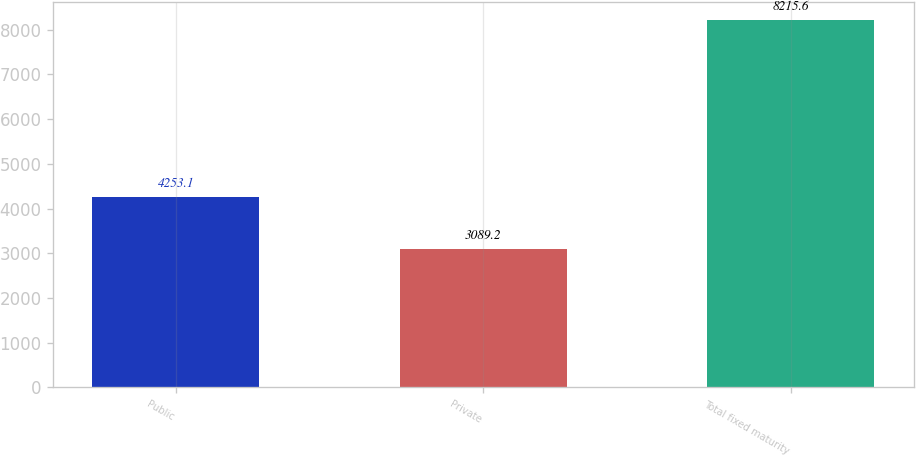Convert chart. <chart><loc_0><loc_0><loc_500><loc_500><bar_chart><fcel>Public<fcel>Private<fcel>Total fixed maturity<nl><fcel>4253.1<fcel>3089.2<fcel>8215.6<nl></chart> 